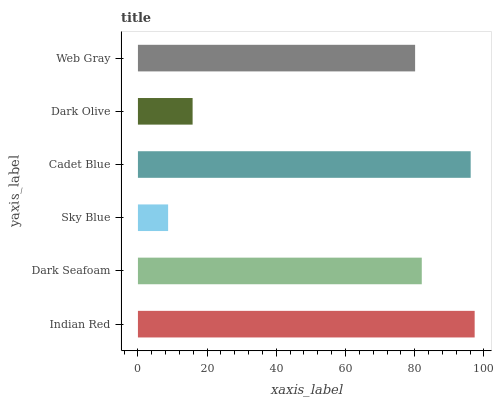Is Sky Blue the minimum?
Answer yes or no. Yes. Is Indian Red the maximum?
Answer yes or no. Yes. Is Dark Seafoam the minimum?
Answer yes or no. No. Is Dark Seafoam the maximum?
Answer yes or no. No. Is Indian Red greater than Dark Seafoam?
Answer yes or no. Yes. Is Dark Seafoam less than Indian Red?
Answer yes or no. Yes. Is Dark Seafoam greater than Indian Red?
Answer yes or no. No. Is Indian Red less than Dark Seafoam?
Answer yes or no. No. Is Dark Seafoam the high median?
Answer yes or no. Yes. Is Web Gray the low median?
Answer yes or no. Yes. Is Dark Olive the high median?
Answer yes or no. No. Is Dark Seafoam the low median?
Answer yes or no. No. 